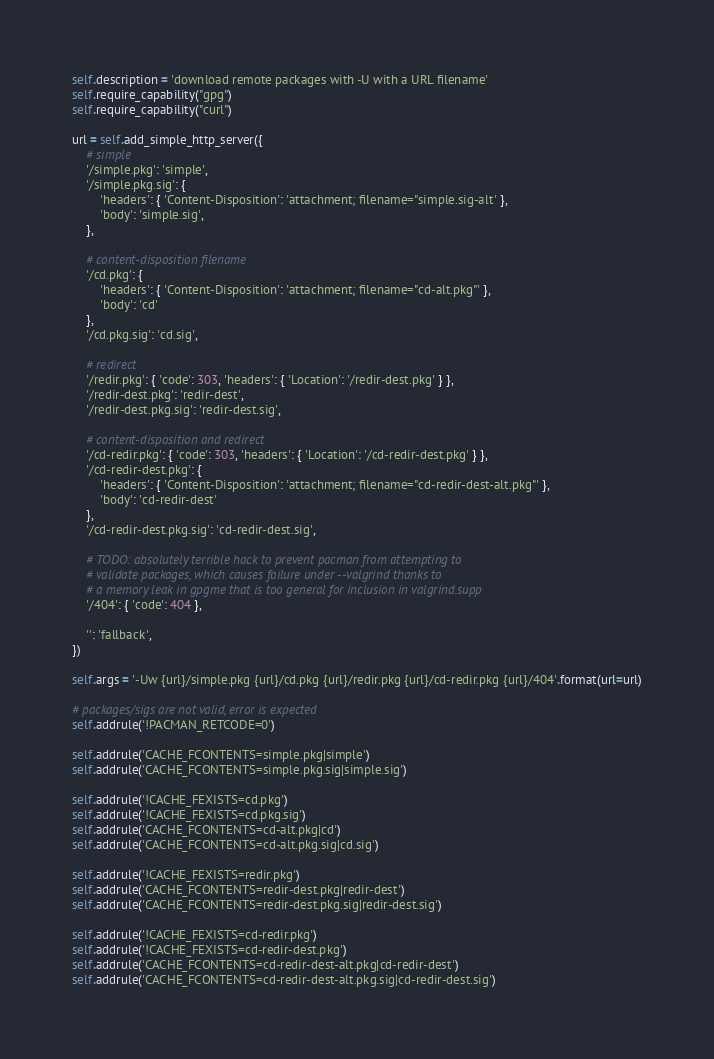<code> <loc_0><loc_0><loc_500><loc_500><_Python_>self.description = 'download remote packages with -U with a URL filename'
self.require_capability("gpg")
self.require_capability("curl")

url = self.add_simple_http_server({
    # simple
    '/simple.pkg': 'simple',
    '/simple.pkg.sig': {
        'headers': { 'Content-Disposition': 'attachment; filename="simple.sig-alt' },
        'body': 'simple.sig',
    },

    # content-disposition filename
    '/cd.pkg': {
        'headers': { 'Content-Disposition': 'attachment; filename="cd-alt.pkg"' },
        'body': 'cd'
    },
    '/cd.pkg.sig': 'cd.sig',

    # redirect
    '/redir.pkg': { 'code': 303, 'headers': { 'Location': '/redir-dest.pkg' } },
    '/redir-dest.pkg': 'redir-dest',
    '/redir-dest.pkg.sig': 'redir-dest.sig',

    # content-disposition and redirect
    '/cd-redir.pkg': { 'code': 303, 'headers': { 'Location': '/cd-redir-dest.pkg' } },
    '/cd-redir-dest.pkg': {
        'headers': { 'Content-Disposition': 'attachment; filename="cd-redir-dest-alt.pkg"' },
        'body': 'cd-redir-dest'
    },
    '/cd-redir-dest.pkg.sig': 'cd-redir-dest.sig',

    # TODO: absolutely terrible hack to prevent pacman from attempting to
    # validate packages, which causes failure under --valgrind thanks to
    # a memory leak in gpgme that is too general for inclusion in valgrind.supp
    '/404': { 'code': 404 },

    '': 'fallback',
})

self.args = '-Uw {url}/simple.pkg {url}/cd.pkg {url}/redir.pkg {url}/cd-redir.pkg {url}/404'.format(url=url)

# packages/sigs are not valid, error is expected
self.addrule('!PACMAN_RETCODE=0')

self.addrule('CACHE_FCONTENTS=simple.pkg|simple')
self.addrule('CACHE_FCONTENTS=simple.pkg.sig|simple.sig')

self.addrule('!CACHE_FEXISTS=cd.pkg')
self.addrule('!CACHE_FEXISTS=cd.pkg.sig')
self.addrule('CACHE_FCONTENTS=cd-alt.pkg|cd')
self.addrule('CACHE_FCONTENTS=cd-alt.pkg.sig|cd.sig')

self.addrule('!CACHE_FEXISTS=redir.pkg')
self.addrule('CACHE_FCONTENTS=redir-dest.pkg|redir-dest')
self.addrule('CACHE_FCONTENTS=redir-dest.pkg.sig|redir-dest.sig')

self.addrule('!CACHE_FEXISTS=cd-redir.pkg')
self.addrule('!CACHE_FEXISTS=cd-redir-dest.pkg')
self.addrule('CACHE_FCONTENTS=cd-redir-dest-alt.pkg|cd-redir-dest')
self.addrule('CACHE_FCONTENTS=cd-redir-dest-alt.pkg.sig|cd-redir-dest.sig')
</code> 